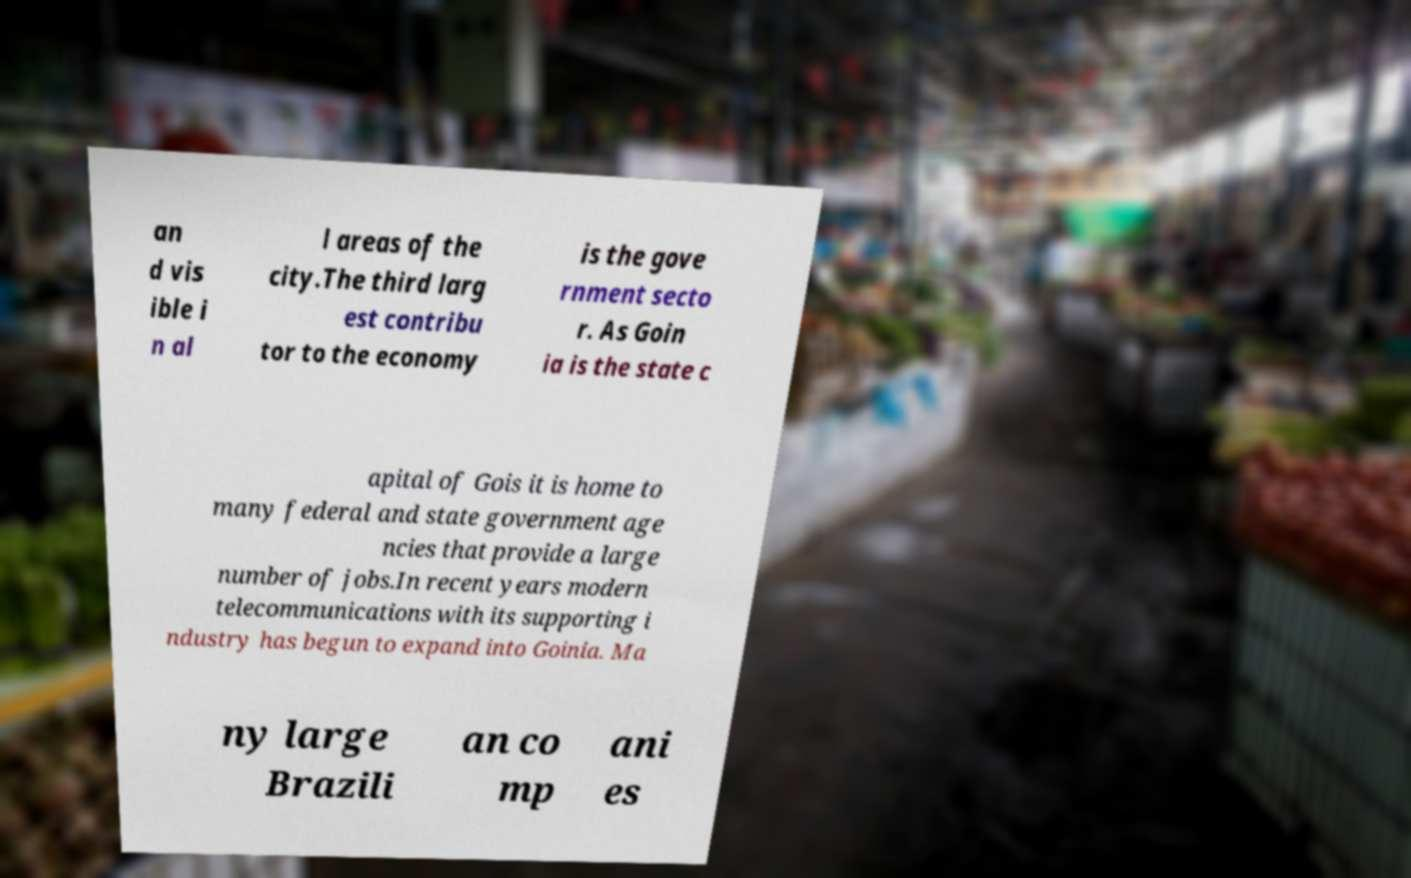What messages or text are displayed in this image? I need them in a readable, typed format. an d vis ible i n al l areas of the city.The third larg est contribu tor to the economy is the gove rnment secto r. As Goin ia is the state c apital of Gois it is home to many federal and state government age ncies that provide a large number of jobs.In recent years modern telecommunications with its supporting i ndustry has begun to expand into Goinia. Ma ny large Brazili an co mp ani es 